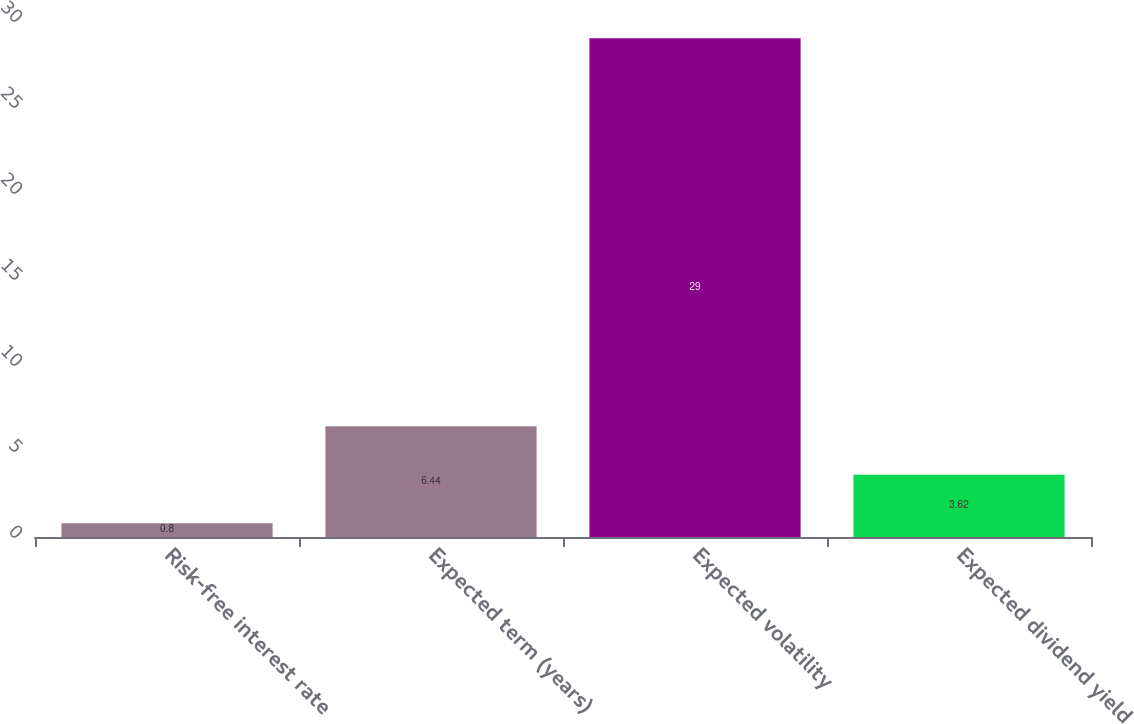Convert chart to OTSL. <chart><loc_0><loc_0><loc_500><loc_500><bar_chart><fcel>Risk-free interest rate<fcel>Expected term (years)<fcel>Expected volatility<fcel>Expected dividend yield<nl><fcel>0.8<fcel>6.44<fcel>29<fcel>3.62<nl></chart> 